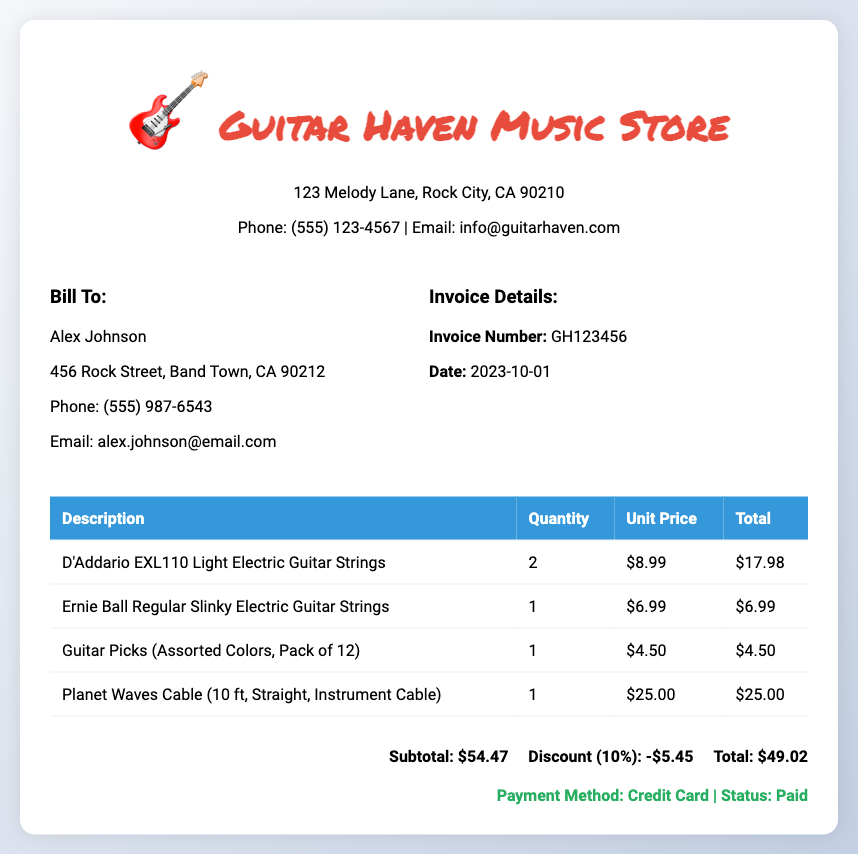What is the invoice number? The invoice number is explicitly listed in the document under invoice details.
Answer: GH123456 How many D'Addario strings were purchased? The quantity of D'Addario strings is provided in the itemized list.
Answer: 2 What is the total amount before discount? The subtotal before any discounts appears at the bottom of the invoice.
Answer: $54.47 What type of guitar strings does Ernie Ball offer in this invoice? The description of the Ernie Ball strings is provided in the itemized list.
Answer: Regular Slinky Electric Guitar Strings How much was the discount applied? The discount amount is detailed in the total section of the invoice.
Answer: -$5.45 What was the payment method used? The payment method is discussed at the bottom of the invoice document.
Answer: Credit Card How much is the total after discount? The total following the discount is shown in the total section of the invoice.
Answer: $49.02 What is the address of Guitar Haven Music Store? The store's address is located in the header section of the invoice.
Answer: 123 Melody Lane, Rock City, CA 90210 